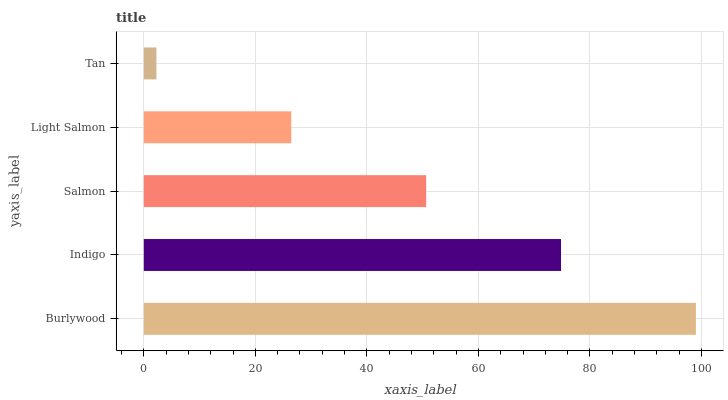Is Tan the minimum?
Answer yes or no. Yes. Is Burlywood the maximum?
Answer yes or no. Yes. Is Indigo the minimum?
Answer yes or no. No. Is Indigo the maximum?
Answer yes or no. No. Is Burlywood greater than Indigo?
Answer yes or no. Yes. Is Indigo less than Burlywood?
Answer yes or no. Yes. Is Indigo greater than Burlywood?
Answer yes or no. No. Is Burlywood less than Indigo?
Answer yes or no. No. Is Salmon the high median?
Answer yes or no. Yes. Is Salmon the low median?
Answer yes or no. Yes. Is Indigo the high median?
Answer yes or no. No. Is Light Salmon the low median?
Answer yes or no. No. 